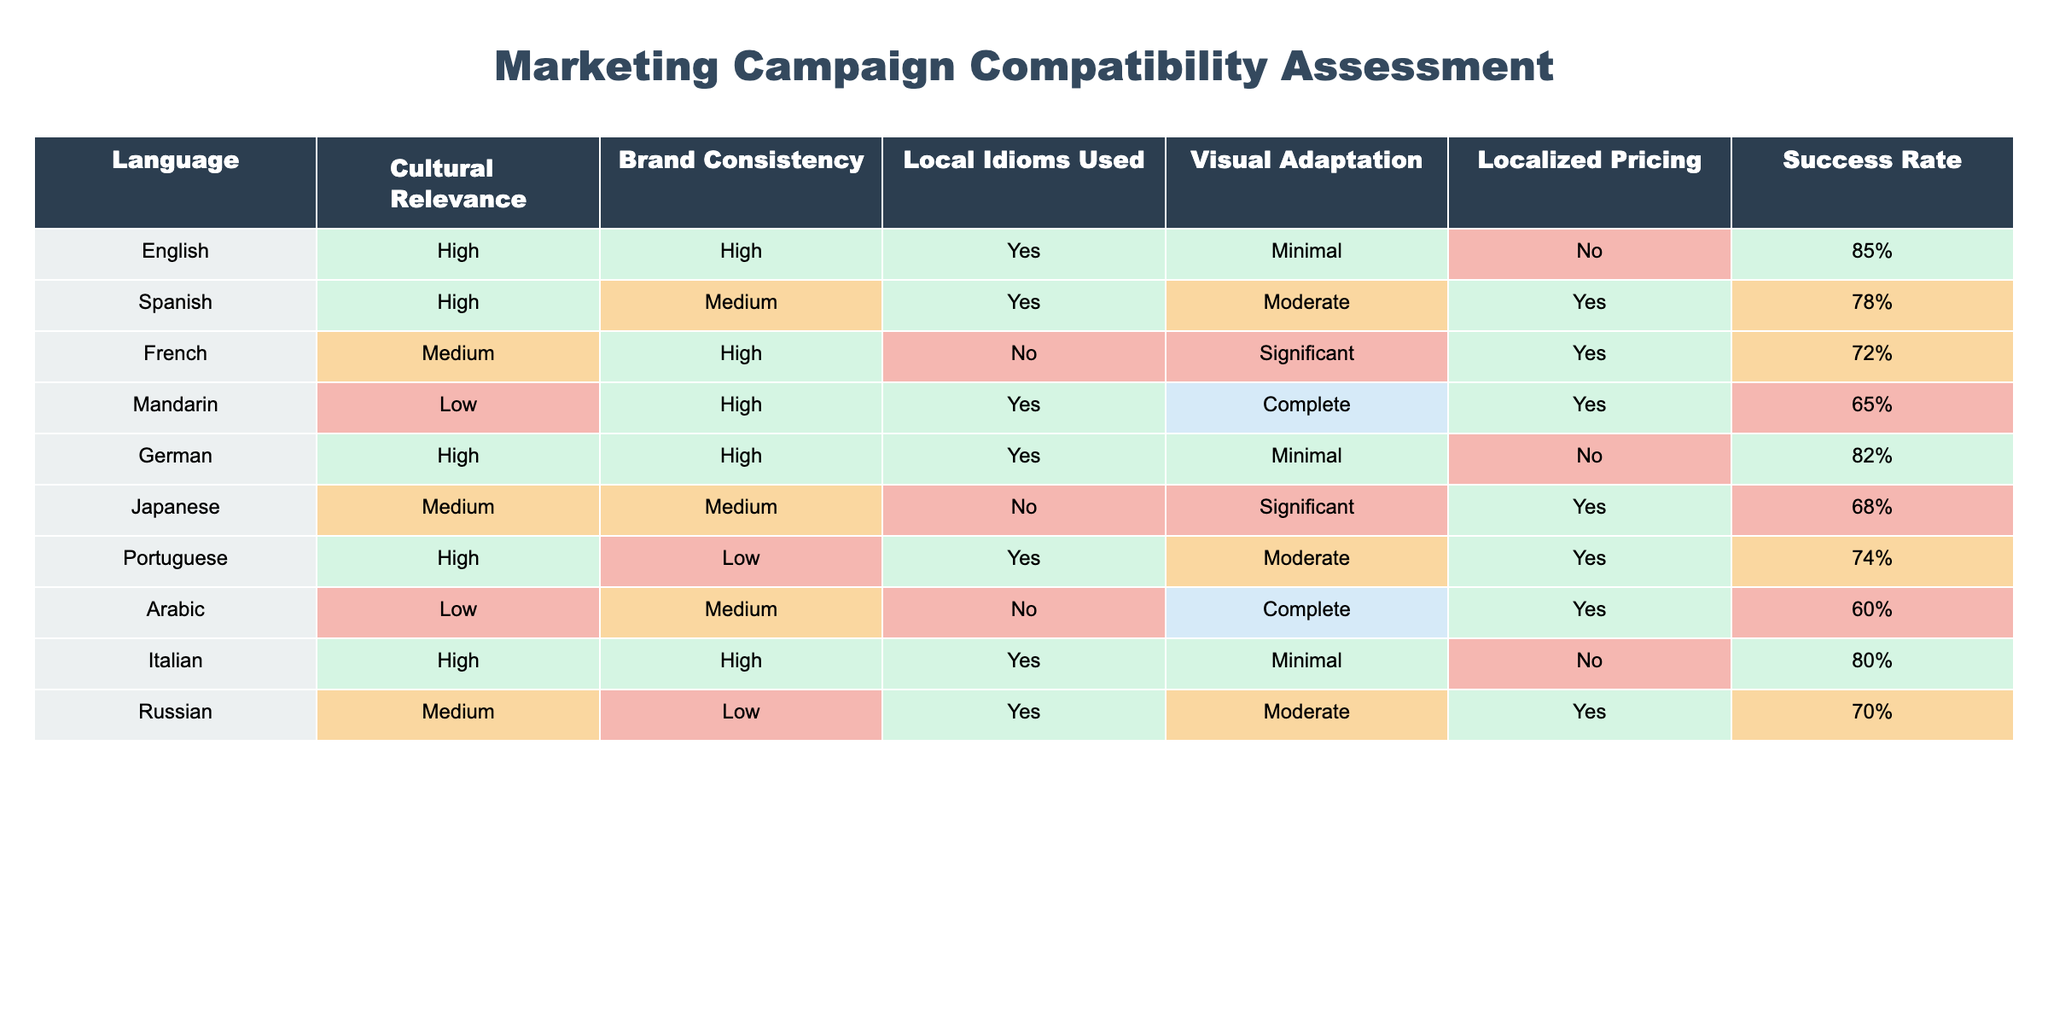What is the success rate for the Mandarin campaign? The success rate for the Mandarin campaign is directly listed in the table under the "Success Rate" column, which shows 65%.
Answer: 65% Which language has the highest cultural relevance? By reviewing the "Cultural Relevance" column, we see that English, Spanish, German, and Portuguese all have a "High" rating, but only one has the highest success rate among those, which is English at 85%.
Answer: English How many languages have a success rate of 70% or higher? The success rates for each language are: English (85%), Spanish (78%), German (82%), Italian (80%), and Portuguese (74%). Counting these, we find that 5 languages (English, Spanish, German, Italian, and Portuguese) have a success rate of 70% or higher.
Answer: 5 Does the Arabic campaign use local idioms? In the table, the "Local Idioms Used" for Arabic is marked as "No," therefore it does not use local idioms.
Answer: No What is the average success rate for campaigns with high cultural relevance? The success rates for languages with high cultural relevance are: English (85%), Spanish (78%), German (82%), and Portuguese (74%). Adding these together gives 85 + 78 + 82 + 74 = 319. There are 4 campaigns, so the average success rate is 319 / 4 = 79.75%.
Answer: 79.75% What is the total number of languages that adapted visuals significantly or completely? Based on the "Visual Adaptation" column, the languages that have either "Significant" or "Complete" adaptation are French (Significant), Japanese (Significant), Mandarin (Complete), and Arabic (Complete). This gives a total of 4 languages.
Answer: 4 Is there any language that has high brand consistency and low localized pricing? Looking at the "Brand Consistency" and "Localized Pricing" columns, we see that only Portuguese is marked as "High" in brand consistency and "Yes" in localized pricing. Therefore, the answer is No.
Answer: No Which language has the lowest success rate among those with high brand consistency? The languages with high brand consistency are English, French, German, and Italian. Their success rates are 85%, 72%, 82%, and 80%, respectively. The lowest success rate among these is for French at 72%.
Answer: French 